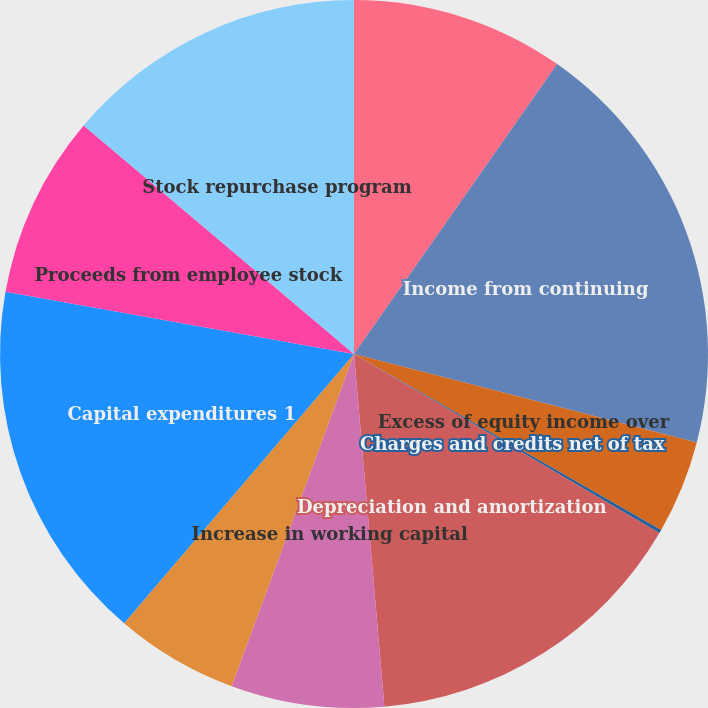Convert chart to OTSL. <chart><loc_0><loc_0><loc_500><loc_500><pie_chart><fcel>Net Debt beginning of year<fcel>Income from continuing<fcel>Excess of equity income over<fcel>Charges and credits net of tax<fcel>Depreciation and amortization<fcel>Increase in working capital<fcel>US qualified pension and<fcel>Capital expenditures 1<fcel>Proceeds from employee stock<fcel>Stock repurchase program<nl><fcel>9.73%<fcel>19.29%<fcel>4.26%<fcel>0.16%<fcel>15.19%<fcel>6.99%<fcel>5.63%<fcel>16.56%<fcel>8.36%<fcel>13.83%<nl></chart> 